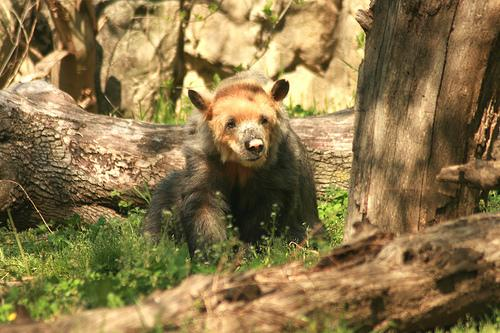Provide a brief description of the prominent animal figure and its surroundings in the image. A brown bear with distinct facial features is sitting in the woods, surrounded by tall grass, a large fallen log, and trees. Characterize the primary focal point of the image and the primary elements in its immediate vicinity. The image's primary subject is a brown bear sitting with visible facial features, surrounded by grass, a fallen tree, a log, and a standing tree. Briefly illustrate the dominant subject of the image along with its facial details and the natural scene around it. The image captures a sitting brown bear, showing its face clearly, with tall grass and a mix of logs and trees in the background. Mention the key elements in the image focusing on the creature and its nearby environment. Image showcases a brown bear seated among tall grass, with a large log, fallen tree, and a standing tree in proximity. Concisely depict the main entity in the image and its surroundings with a focus on vegetation and other natural elements. A brown bear sits amid tall grass, near a large log, a fallen tree, and another standing tree - creating a serene natural scene. In a concise manner, depict the main character's state and describe its immediate setting. A seated brown bear is in the midst of tall grass, close to a large log, a fallen tree, and a standing tree. Elaborate on the animal figure in the image and the principal features of its habitat. A sitting brown bear with well-defined facial features is positioned near tall grass, a sizable log, a fallen tree, and a standing tree. Summarize the primary subject in the image along with its facial characteristics and elements of nature around it. The image presents a sitting brown bear with a well-defined face, surrounded by tall grass, a large log, a fallen tree, and a standing tree. Provide an overview of the central figure in the image and the various aspects of its setting. The image highlights a brown bear with distinguishable facial features sitting in a natural environment featuring grass and different types of trees. Narrate a short account of the living being shown in the image and the environment it is occupying. In the image, a brown bear is sitting in a wooded area surrounded by tall grass, a large fallen log, and a couple of trees. 